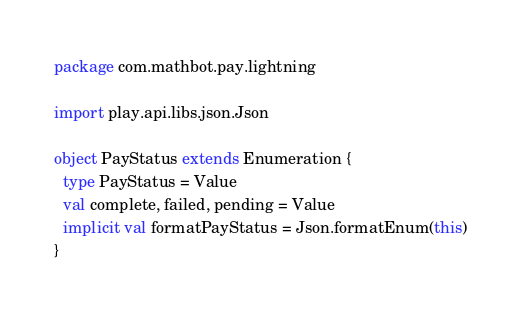<code> <loc_0><loc_0><loc_500><loc_500><_Scala_>package com.mathbot.pay.lightning

import play.api.libs.json.Json

object PayStatus extends Enumeration {
  type PayStatus = Value
  val complete, failed, pending = Value
  implicit val formatPayStatus = Json.formatEnum(this)
}
</code> 